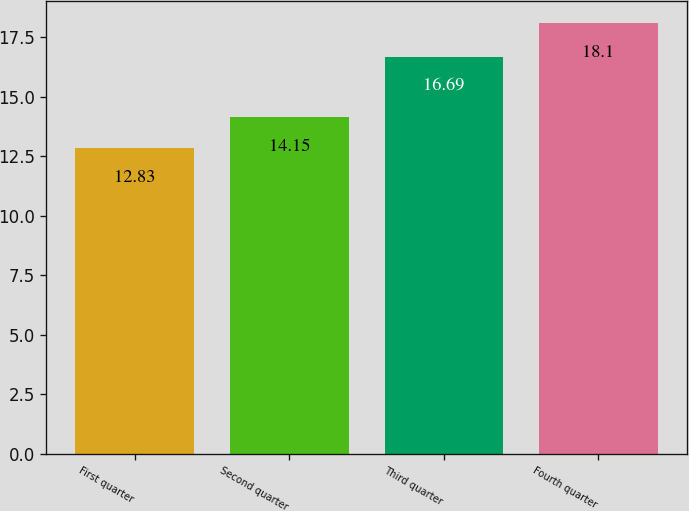Convert chart to OTSL. <chart><loc_0><loc_0><loc_500><loc_500><bar_chart><fcel>First quarter<fcel>Second quarter<fcel>Third quarter<fcel>Fourth quarter<nl><fcel>12.83<fcel>14.15<fcel>16.69<fcel>18.1<nl></chart> 